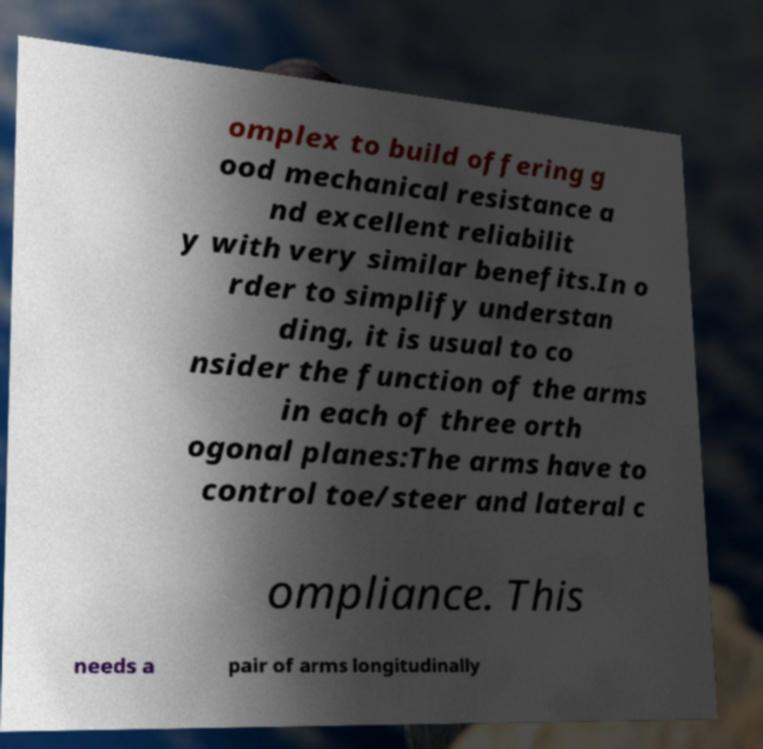Please identify and transcribe the text found in this image. omplex to build offering g ood mechanical resistance a nd excellent reliabilit y with very similar benefits.In o rder to simplify understan ding, it is usual to co nsider the function of the arms in each of three orth ogonal planes:The arms have to control toe/steer and lateral c ompliance. This needs a pair of arms longitudinally 